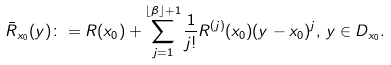Convert formula to latex. <formula><loc_0><loc_0><loc_500><loc_500>\bar { R } _ { x _ { 0 } } ( y ) \colon = R ( x _ { 0 } ) + \sum _ { j = 1 } ^ { \lfloor \beta \rfloor + 1 } \frac { 1 } { j ! } R ^ { ( j ) } ( x _ { 0 } ) ( y - x _ { 0 } ) ^ { j } , \, y \in D _ { x _ { 0 } } .</formula> 